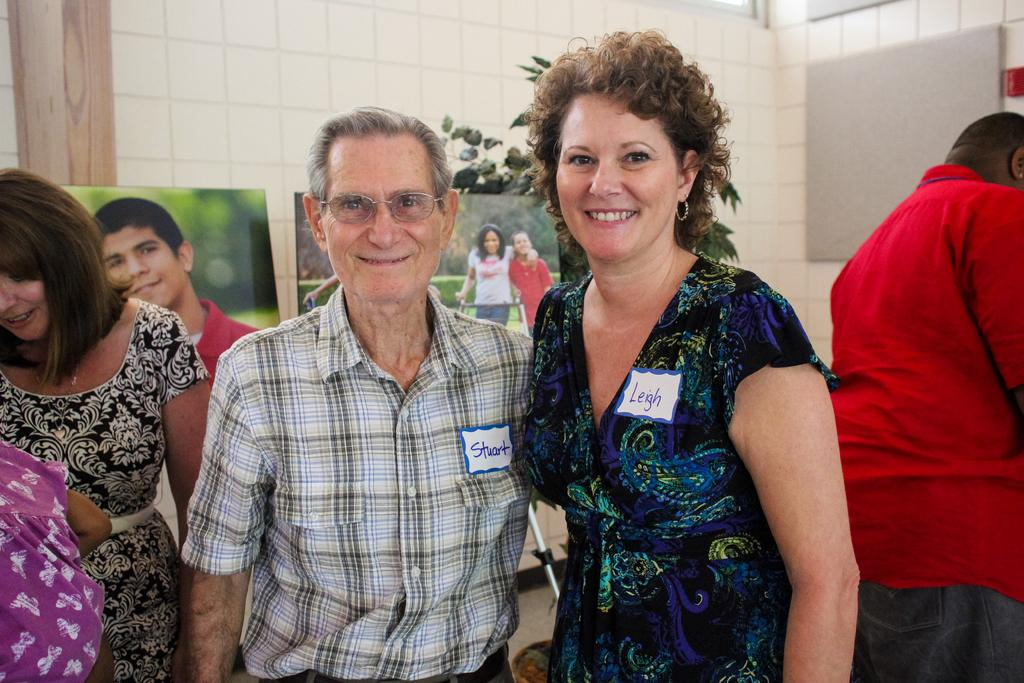What can be seen in the image involving people? There are people standing in the image. What objects are present in the image that are related to photography? There are photo frames in the image. What type of vegetation is visible in the image? There is a plant in the image. What can be seen in the background of the image? There is a wall in the background of the image. How many ladybugs are crawling on the wall in the image? There are no ladybugs present in the image; only people, photo frames, a plant, and a wall are visible. What type of corn is growing in the image? There is no corn present in the image. 